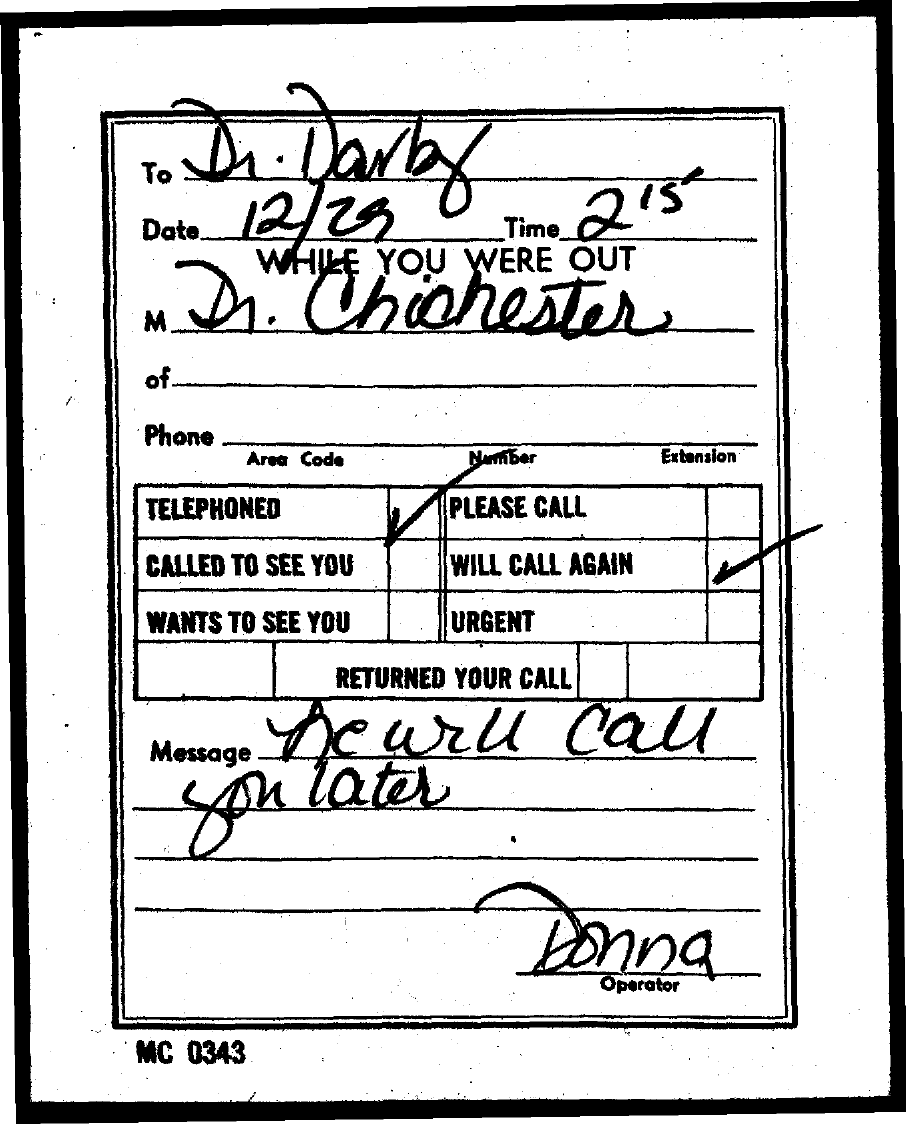To Whom is this note addressed to?
Offer a very short reply. Dr. Darby. What is the Date?
Ensure brevity in your answer.  12/29. What is the time?
Offer a terse response. 215. Who left the message?
Keep it short and to the point. Dr. Chichester. What is the message?
Make the answer very short. He will call you later. Who is the operator?
Your response must be concise. Donna. 